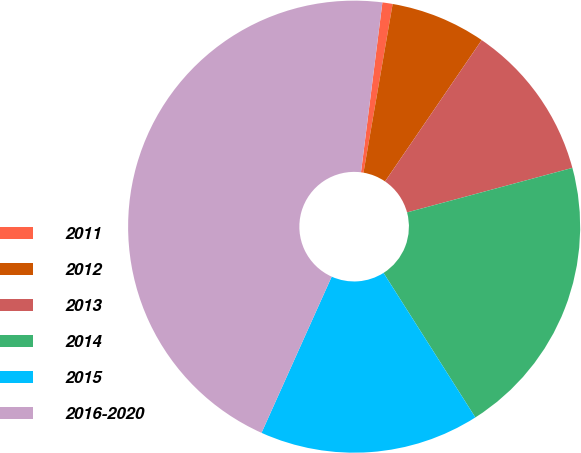Convert chart. <chart><loc_0><loc_0><loc_500><loc_500><pie_chart><fcel>2011<fcel>2012<fcel>2013<fcel>2014<fcel>2015<fcel>2016-2020<nl><fcel>0.73%<fcel>6.82%<fcel>11.27%<fcel>20.18%<fcel>15.73%<fcel>45.28%<nl></chart> 